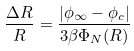Convert formula to latex. <formula><loc_0><loc_0><loc_500><loc_500>\frac { \Delta R } { R } = \frac { | \phi _ { \infty } - \phi _ { c } | } { 3 \beta \Phi _ { N } ( R ) }</formula> 